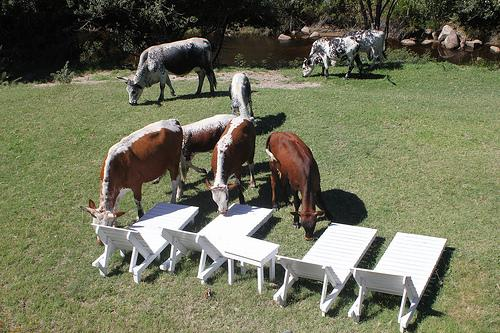What type of furniture can be seen in the image? There are four white wooden lounge chairs and a white wooden side table. In the context of the image, describe the relationship between the cows and the lounge chairs. The cows are grazing near the lounge chairs, some of them are sniffing or approaching the chairs, which seem to be in their grazing area. What type of plants are visible in the environment? There are green brush and foliage, and another unidentified plant on the ground. Explain what the cows in the image are doing. The cows in the image form a herd that is grazing on grass, some are sniffing at lounge chairs while others are eating. What colors and patterns can we see in the different cows grazing? The cows have diverse colors and patterns such as black and white, brown and white, dark brown, spotted white, and a brown one with a white stripe. Identify the animal with its distinctive feature in the scene. A black and white cow with spots is grazing on grass in the distance. Analyze the image's sentiment by describing the atmosphere it conveys. The image conveys a calm and peaceful setting with cows grazing near lawn chairs, and a lake in the distance. What is the landscape feature found behind the cows? There is a body of water, specifically a lake with a rocky shoreline, behind the cows. Describe the setting of the image, particularly the ground and surrounding nature. There's a patch of green grass with green brush and foliage, a body of water is nearby, and large grey rocks border the area. What can be seen near the white lounge chairs? There is a small white table, and a brown and white cow sniffing at a lounge chair. 